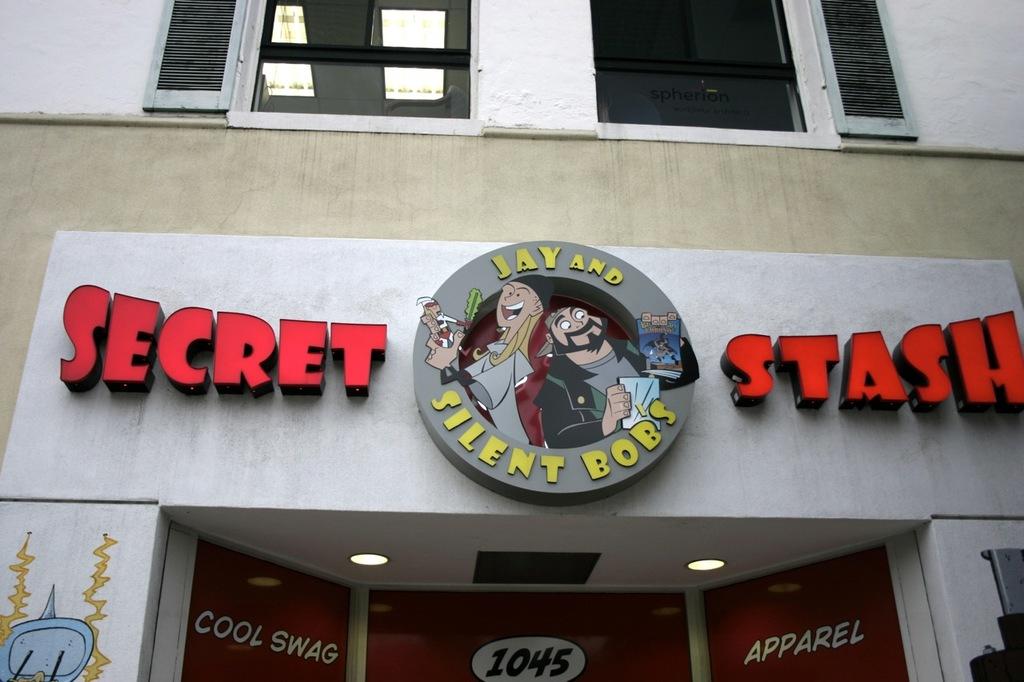Is that a pot store?
Offer a very short reply. No. What's the name of the shop?
Offer a terse response. Secret stash. 